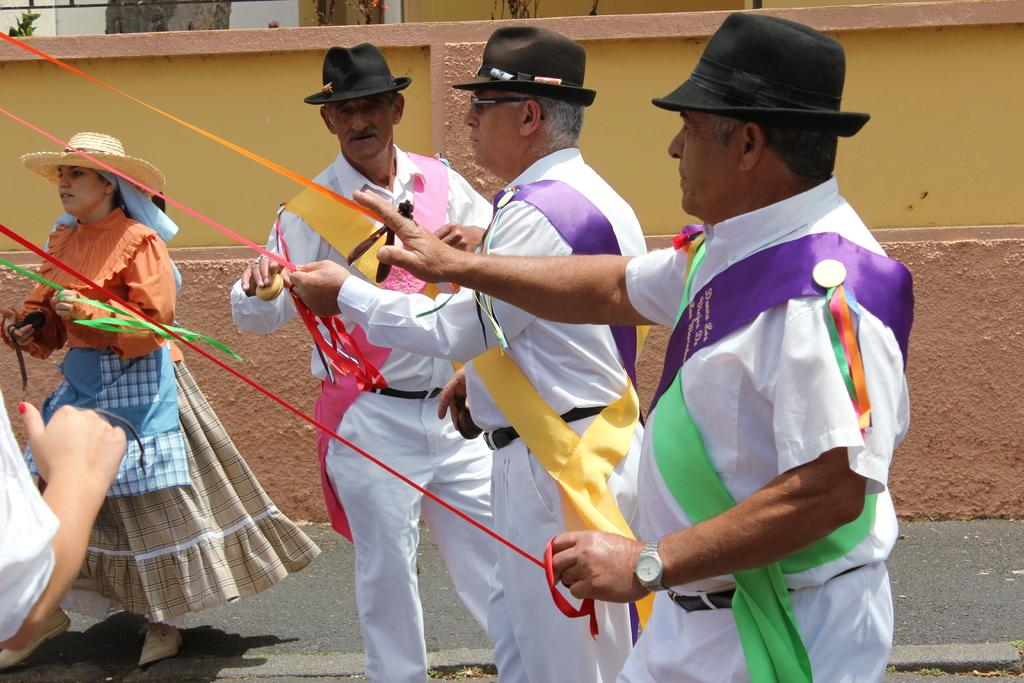What types of people are present in the image? There are men and women in the image. What are the people doing in the image? The people are standing. What can be seen in the background of the image? There is a wall in the background of the image. What type of waves can be seen crashing against the shore in the image? There are no waves present in the image; it features men and women standing in front of a wall. 